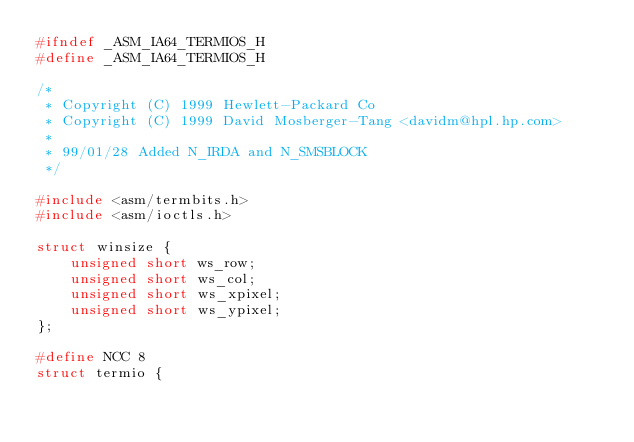<code> <loc_0><loc_0><loc_500><loc_500><_C_>#ifndef _ASM_IA64_TERMIOS_H
#define _ASM_IA64_TERMIOS_H

/*
 * Copyright (C) 1999 Hewlett-Packard Co
 * Copyright (C) 1999 David Mosberger-Tang <davidm@hpl.hp.com>
 *
 * 99/01/28	Added N_IRDA and N_SMSBLOCK
 */

#include <asm/termbits.h>
#include <asm/ioctls.h>

struct winsize {
	unsigned short ws_row;
	unsigned short ws_col;
	unsigned short ws_xpixel;
	unsigned short ws_ypixel;
};

#define NCC 8
struct termio {</code> 